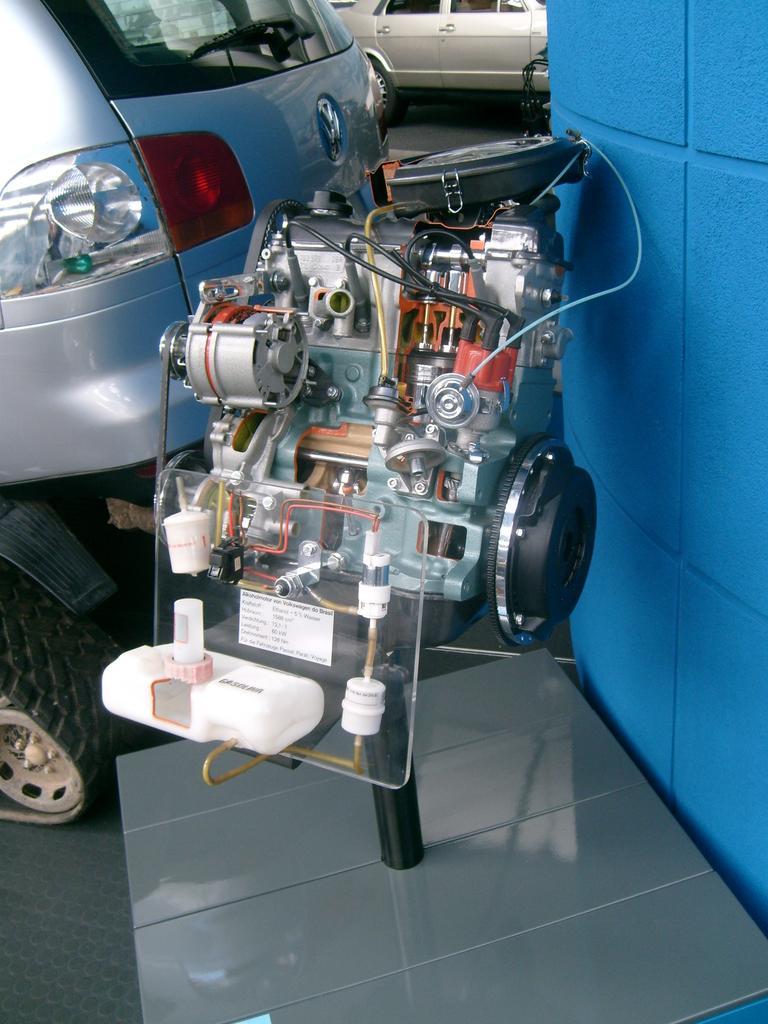How would you summarize this image in a sentence or two? In this picture there is a machine in the foreground. At the back there are vehicles. On the right side of the image there is a wall. 